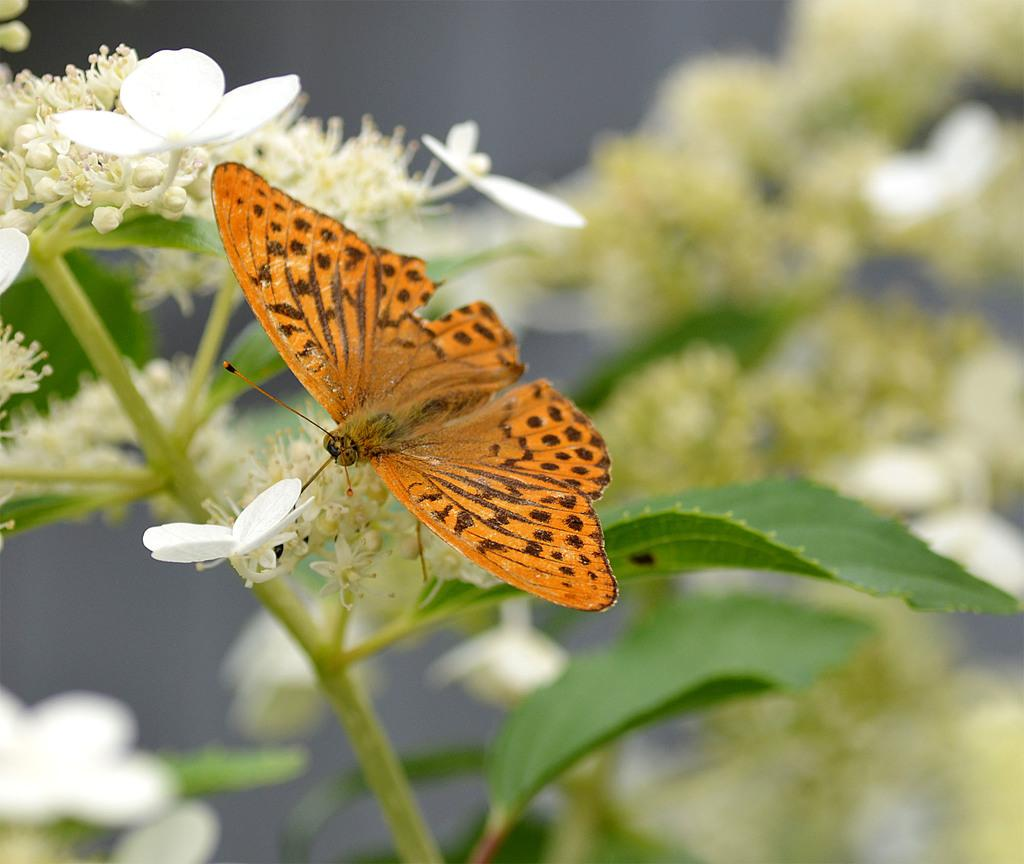What type of plant life can be seen in the image? There are flowers and buds in the image. Are there any other living creatures present in the image? Yes, there is a butterfly in the image. Where are the flowers, buds, and butterfly located? They are all on a plant in the image. What type of lamp can be seen on the ground in the image? There is no lamp present in the image; it features flowers, buds, and a butterfly on a plant. What type of office furniture can be seen in the image? There is no office furniture present in the image; it features flowers, buds, and a butterfly on a plant. 